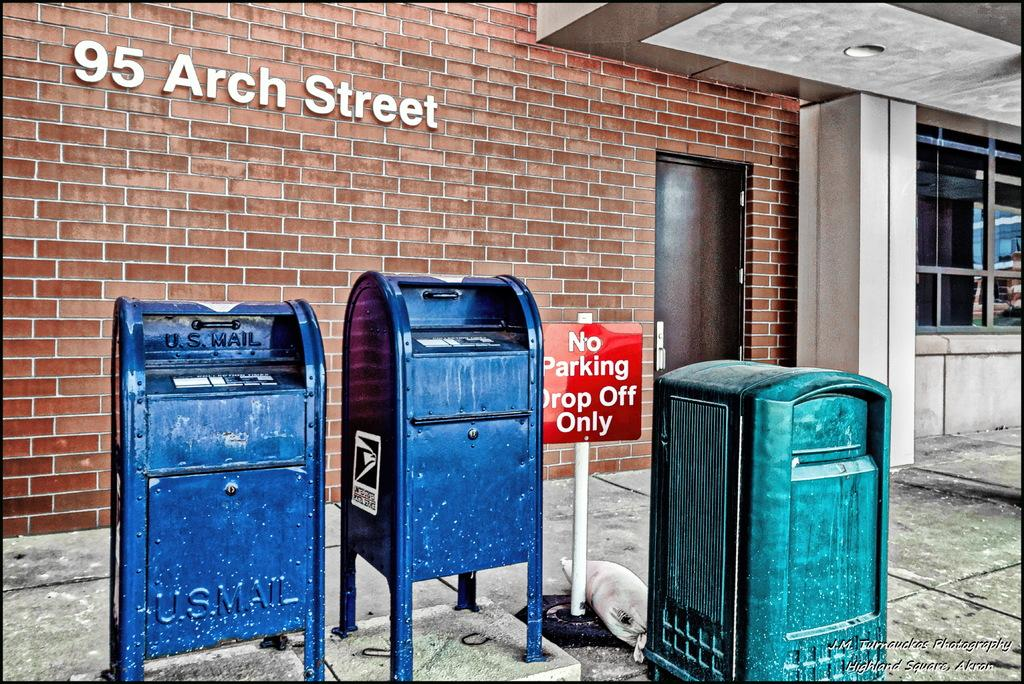<image>
Give a short and clear explanation of the subsequent image. Red sign that says "No Parking" next to a blue mailbox. 